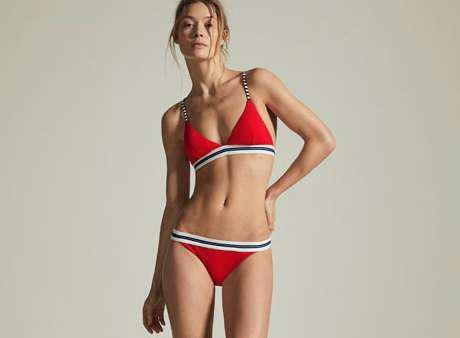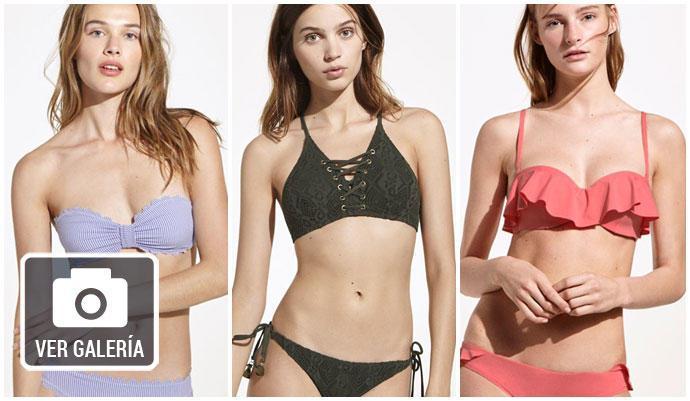The first image is the image on the left, the second image is the image on the right. For the images shown, is this caption "A woman is touching her hair." true? Answer yes or no. No. The first image is the image on the left, the second image is the image on the right. For the images shown, is this caption "One image shows a girl in a bikini with straps and solid color, standing with one hand on her upper hip." true? Answer yes or no. Yes. 